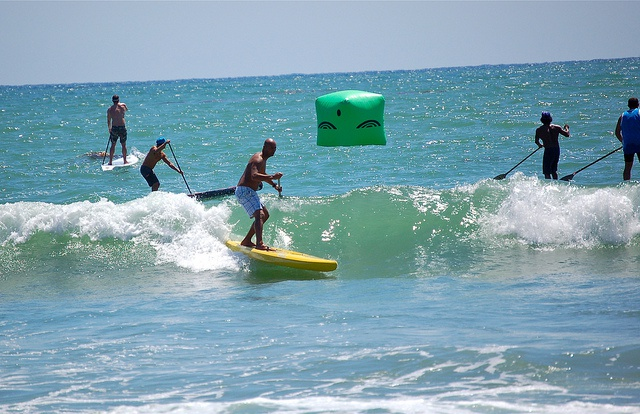Describe the objects in this image and their specific colors. I can see people in lightblue, black, maroon, and gray tones, surfboard in lightblue, olive, khaki, and gold tones, people in lightblue, black, navy, blue, and gray tones, people in lightblue, black, and gray tones, and people in lightblue, black, gray, and purple tones in this image. 